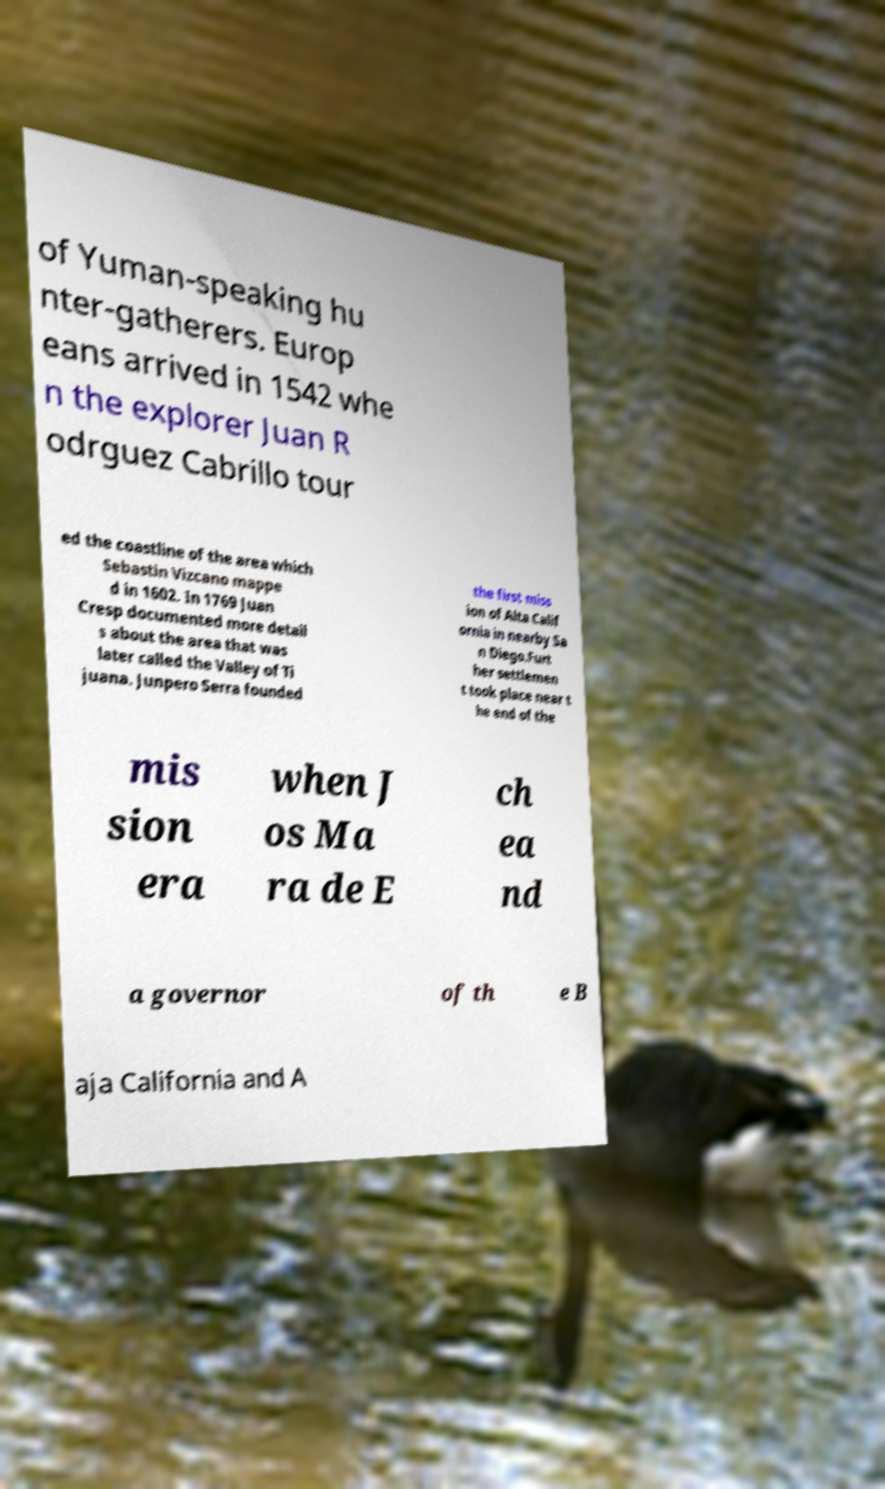There's text embedded in this image that I need extracted. Can you transcribe it verbatim? of Yuman-speaking hu nter-gatherers. Europ eans arrived in 1542 whe n the explorer Juan R odrguez Cabrillo tour ed the coastline of the area which Sebastin Vizcano mappe d in 1602. In 1769 Juan Cresp documented more detail s about the area that was later called the Valley of Ti juana. Junpero Serra founded the first miss ion of Alta Calif ornia in nearby Sa n Diego.Furt her settlemen t took place near t he end of the mis sion era when J os Ma ra de E ch ea nd a governor of th e B aja California and A 